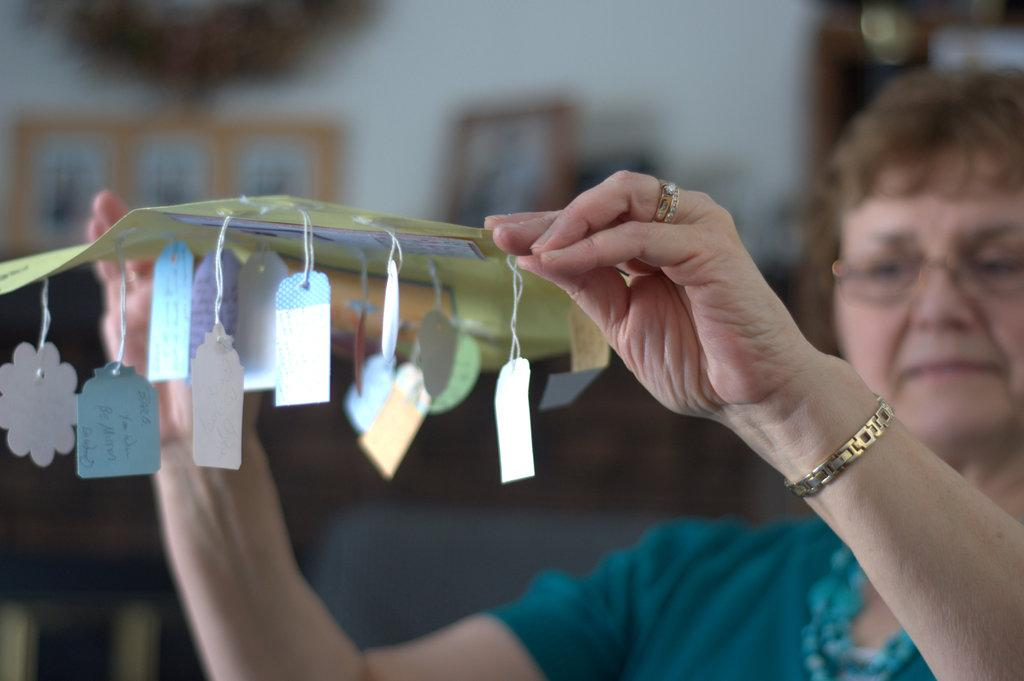What is the woman in the image doing? The woman is sitting in the image. What is the woman holding in the image? The woman is holding a paper. Can you describe the background of the image? The backdrop of the image is blurred. What type of sheet is the woman using to sail in the image? There is no sheet or sailing activity present in the image; the woman is simply sitting and holding a paper. 